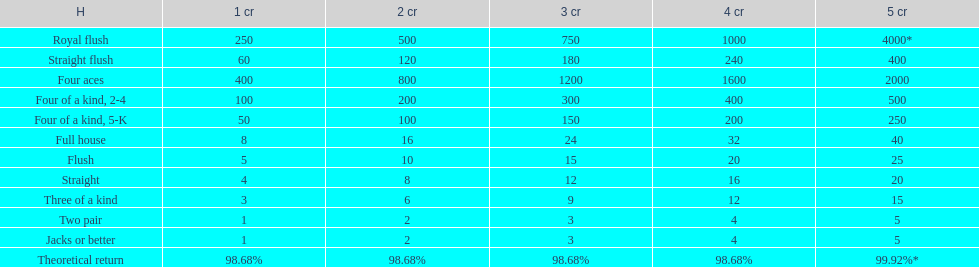Can you parse all the data within this table? {'header': ['H', '1 cr', '2 cr', '3 cr', '4 cr', '5 cr'], 'rows': [['Royal flush', '250', '500', '750', '1000', '4000*'], ['Straight flush', '60', '120', '180', '240', '400'], ['Four aces', '400', '800', '1200', '1600', '2000'], ['Four of a kind, 2-4', '100', '200', '300', '400', '500'], ['Four of a kind, 5-K', '50', '100', '150', '200', '250'], ['Full house', '8', '16', '24', '32', '40'], ['Flush', '5', '10', '15', '20', '25'], ['Straight', '4', '8', '12', '16', '20'], ['Three of a kind', '3', '6', '9', '12', '15'], ['Two pair', '1', '2', '3', '4', '5'], ['Jacks or better', '1', '2', '3', '4', '5'], ['Theoretical return', '98.68%', '98.68%', '98.68%', '98.68%', '99.92%*']]} What is the total amount of a 3 credit straight flush? 180. 